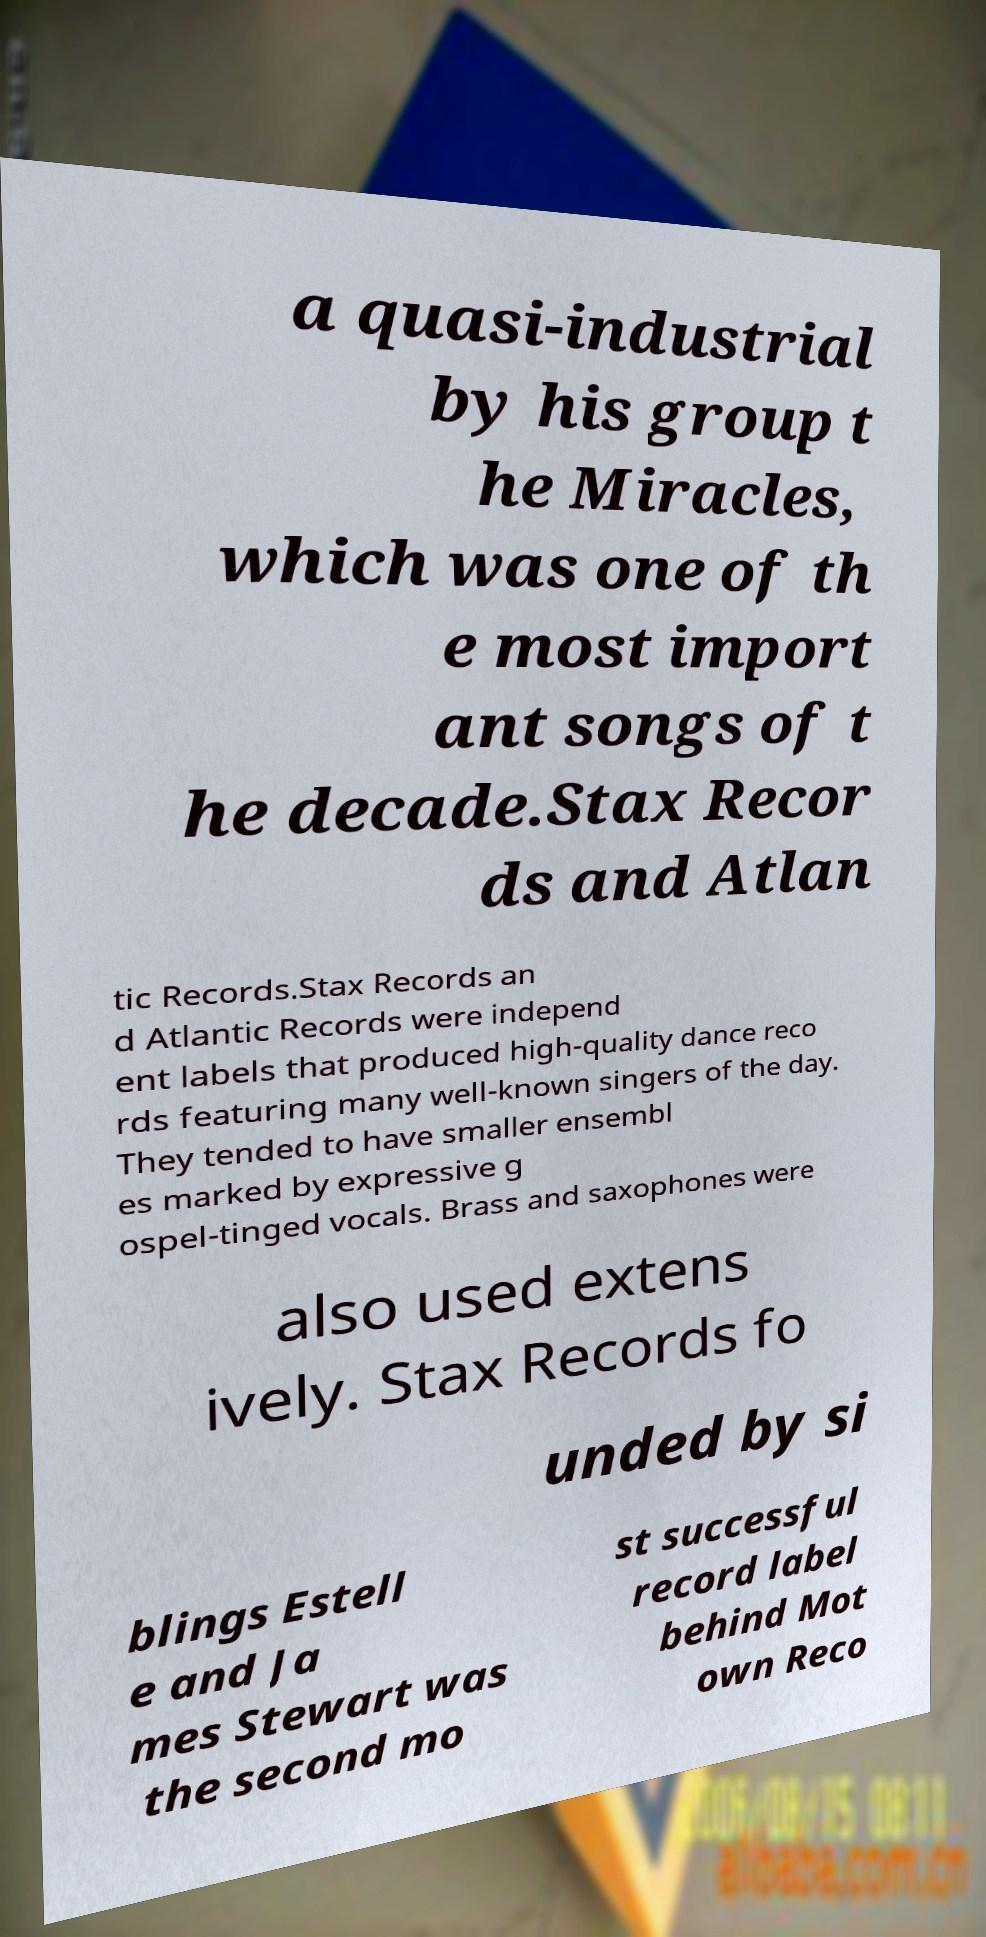For documentation purposes, I need the text within this image transcribed. Could you provide that? a quasi-industrial by his group t he Miracles, which was one of th e most import ant songs of t he decade.Stax Recor ds and Atlan tic Records.Stax Records an d Atlantic Records were independ ent labels that produced high-quality dance reco rds featuring many well-known singers of the day. They tended to have smaller ensembl es marked by expressive g ospel-tinged vocals. Brass and saxophones were also used extens ively. Stax Records fo unded by si blings Estell e and Ja mes Stewart was the second mo st successful record label behind Mot own Reco 